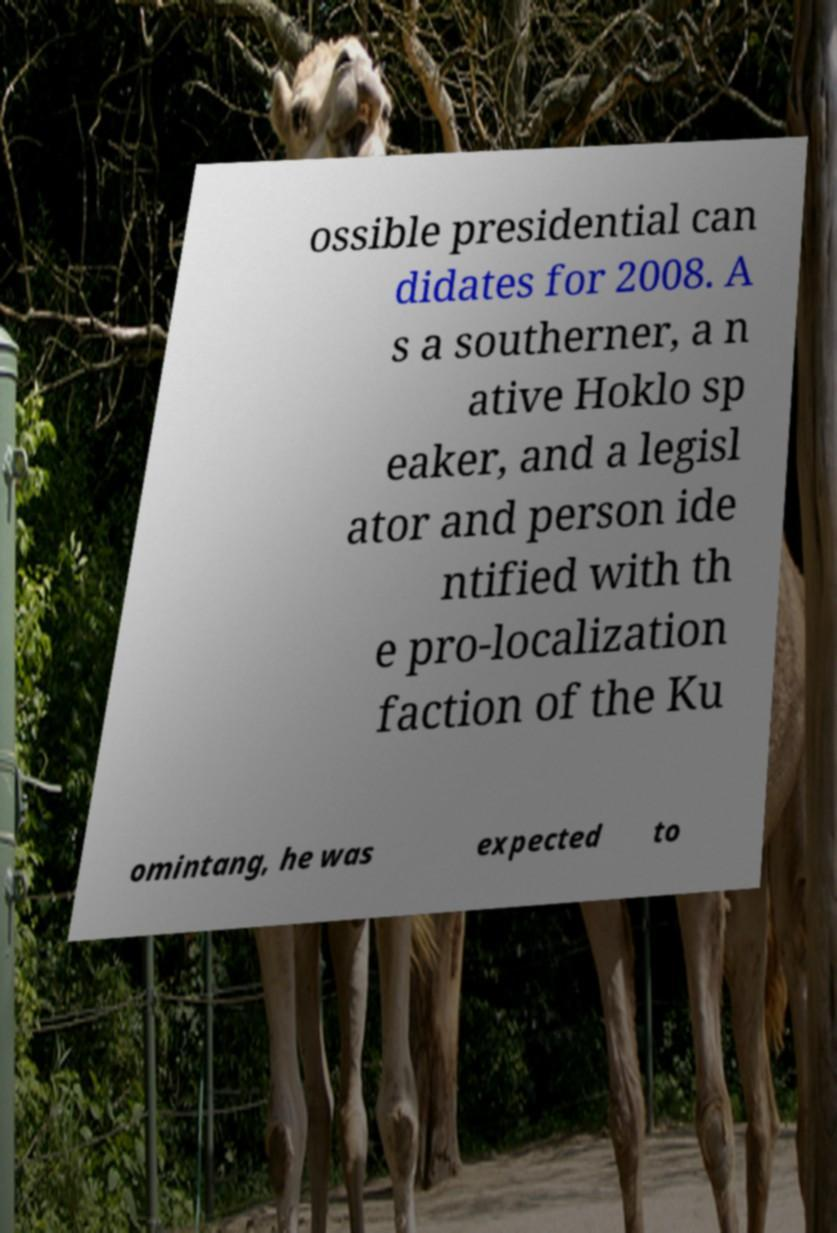I need the written content from this picture converted into text. Can you do that? ossible presidential can didates for 2008. A s a southerner, a n ative Hoklo sp eaker, and a legisl ator and person ide ntified with th e pro-localization faction of the Ku omintang, he was expected to 